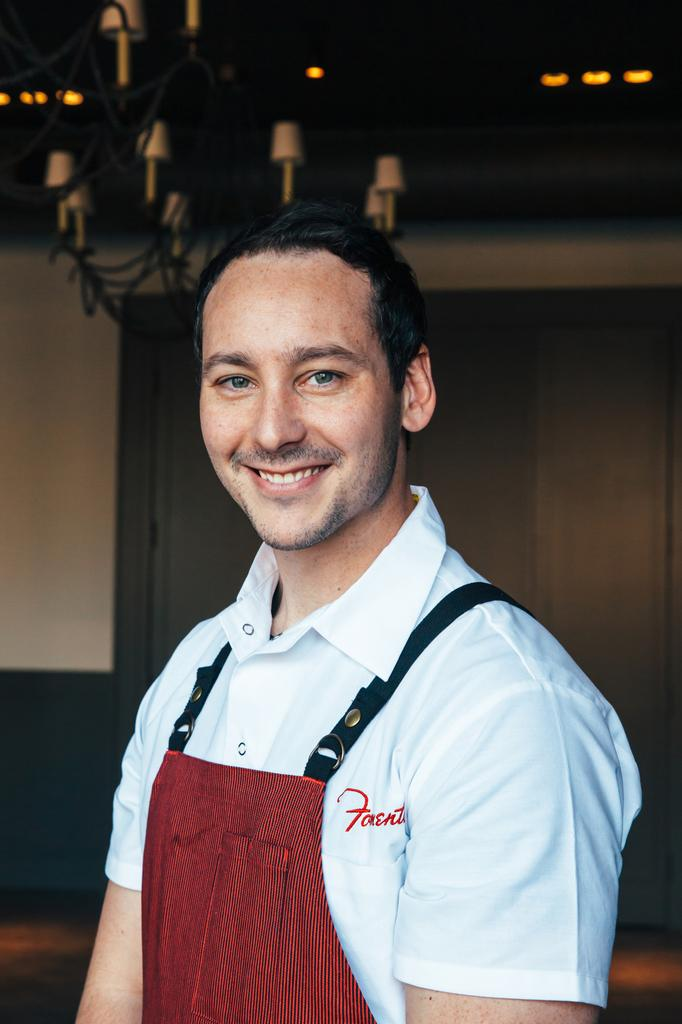<image>
Relay a brief, clear account of the picture shown. A man smiles for the camera in a red apron and white shirt with the partial name "Fonent" legible on it. 